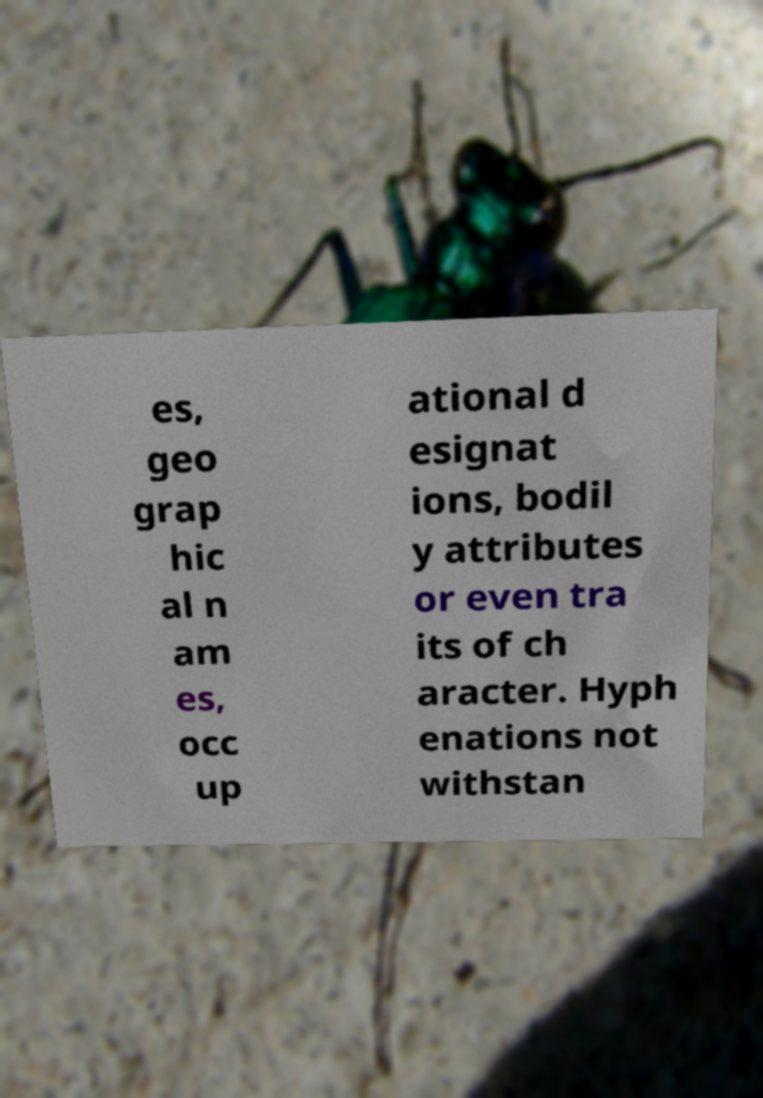For documentation purposes, I need the text within this image transcribed. Could you provide that? es, geo grap hic al n am es, occ up ational d esignat ions, bodil y attributes or even tra its of ch aracter. Hyph enations not withstan 